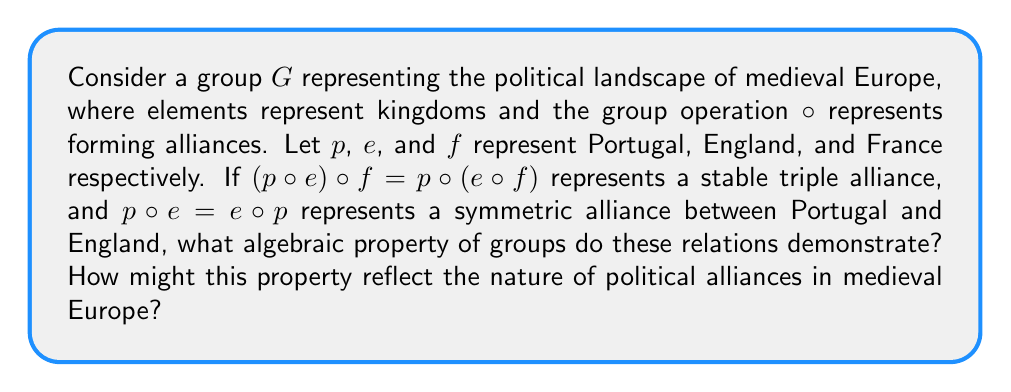Could you help me with this problem? To answer this question, we need to analyze the algebraic properties demonstrated by the given relations:

1. $(p \circ e) \circ f = p \circ (e \circ f)$
This relation demonstrates the associative property of group operations. In the context of alliances, it suggests that the order in which alliances are formed doesn't affect the final outcome of the triple alliance.

2. $p \circ e = e \circ p$
This relation demonstrates the commutative property. However, it's important to note that not all groups are commutative (such groups are called Abelian groups).

The associative property is a fundamental property of all groups, while the commutative property is not. In the context of medieval European alliances:

a) Associativity ($(p \circ e) \circ f = p \circ (e \circ f)$):
This reflects the idea that in forming a triple alliance, the order of negotiations doesn't matter. Whether Portugal allies with England first and then they both ally with France, or England allies with France first and then Portugal joins, the end result is the same triple alliance.

b) Commutativity ($p \circ e = e \circ p$):
This suggests a balanced, symmetric alliance between Portugal and England, where both kingdoms have equal standing. However, the question doesn't state that this property holds for all pairs of kingdoms, reflecting the reality that not all alliances in medieval Europe were equal or reciprocal.

The associative property is the key algebraic property demonstrated here, as it is a defining characteristic of groups. This property reflects the strategic nature of alliance formation in medieval Europe, where the end result of multiple alliances was often more important than the order in which they were formed.
Answer: The associative property of groups, demonstrated by $(p \circ e) \circ f = p \circ (e \circ f)$. This reflects the strategic nature of alliance formation in medieval Europe, where the final configuration of alliances was often more crucial than the sequence of their formation. 